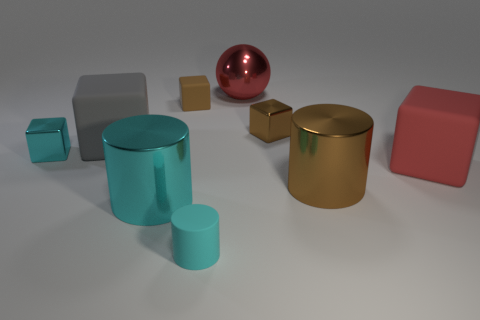Subtract all red blocks. Subtract all purple balls. How many blocks are left? 4 Subtract all spheres. How many objects are left? 8 Add 4 large brown things. How many large brown things exist? 5 Subtract 0 blue cylinders. How many objects are left? 9 Subtract all big metal cylinders. Subtract all large matte cubes. How many objects are left? 5 Add 8 large rubber blocks. How many large rubber blocks are left? 10 